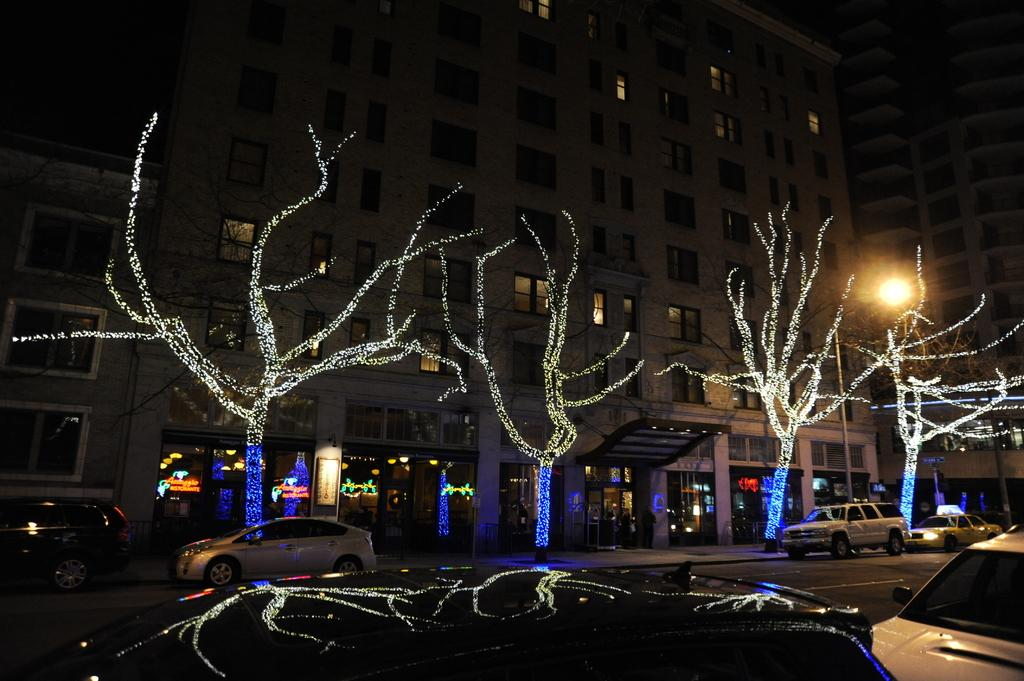What type of lighting is used for the trees in the image? There are fairy lights for the trees in the image. What can be seen on the road in the image? There are vehicles on the road in the image. What is visible in the background of the image? There are buildings and poles in the background of the image. What else can be seen in the background of the image? There are lights visible in the background of the image. Can you tell me how many giants are walking on the road in the image? There are no giants present in the image; it features vehicles on the road. What type of drink is being served in the image? There is no drink being served in the image; it focuses on fairy lights, vehicles, buildings, poles, and lights. 